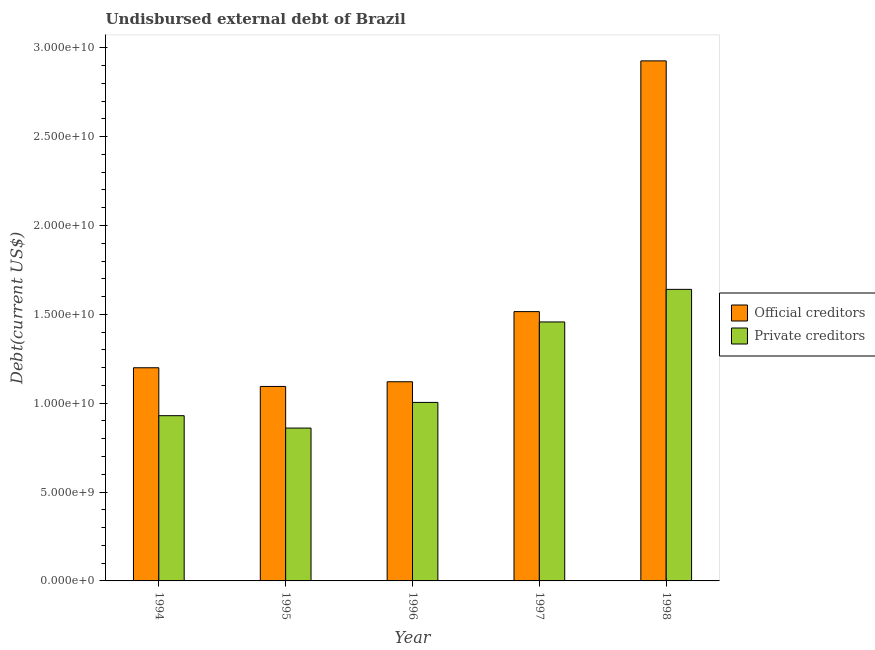Are the number of bars on each tick of the X-axis equal?
Keep it short and to the point. Yes. How many bars are there on the 1st tick from the right?
Provide a short and direct response. 2. What is the undisbursed external debt of private creditors in 1998?
Provide a succinct answer. 1.64e+1. Across all years, what is the maximum undisbursed external debt of private creditors?
Make the answer very short. 1.64e+1. Across all years, what is the minimum undisbursed external debt of private creditors?
Your response must be concise. 8.60e+09. What is the total undisbursed external debt of official creditors in the graph?
Provide a short and direct response. 7.86e+1. What is the difference between the undisbursed external debt of private creditors in 1994 and that in 1995?
Ensure brevity in your answer.  6.97e+08. What is the difference between the undisbursed external debt of private creditors in 1994 and the undisbursed external debt of official creditors in 1998?
Make the answer very short. -7.11e+09. What is the average undisbursed external debt of private creditors per year?
Ensure brevity in your answer.  1.18e+1. What is the ratio of the undisbursed external debt of private creditors in 1995 to that in 1997?
Give a very brief answer. 0.59. Is the undisbursed external debt of private creditors in 1995 less than that in 1998?
Provide a succinct answer. Yes. What is the difference between the highest and the second highest undisbursed external debt of private creditors?
Your answer should be very brief. 1.83e+09. What is the difference between the highest and the lowest undisbursed external debt of official creditors?
Offer a very short reply. 1.83e+1. In how many years, is the undisbursed external debt of official creditors greater than the average undisbursed external debt of official creditors taken over all years?
Make the answer very short. 1. What does the 1st bar from the left in 1995 represents?
Ensure brevity in your answer.  Official creditors. What does the 1st bar from the right in 1998 represents?
Offer a terse response. Private creditors. What is the difference between two consecutive major ticks on the Y-axis?
Make the answer very short. 5.00e+09. Does the graph contain grids?
Offer a terse response. No. How many legend labels are there?
Offer a terse response. 2. How are the legend labels stacked?
Your response must be concise. Vertical. What is the title of the graph?
Your answer should be compact. Undisbursed external debt of Brazil. Does "Resident workers" appear as one of the legend labels in the graph?
Keep it short and to the point. No. What is the label or title of the Y-axis?
Offer a very short reply. Debt(current US$). What is the Debt(current US$) in Official creditors in 1994?
Provide a succinct answer. 1.20e+1. What is the Debt(current US$) in Private creditors in 1994?
Keep it short and to the point. 9.30e+09. What is the Debt(current US$) of Official creditors in 1995?
Your answer should be very brief. 1.09e+1. What is the Debt(current US$) in Private creditors in 1995?
Your answer should be very brief. 8.60e+09. What is the Debt(current US$) of Official creditors in 1996?
Your answer should be compact. 1.12e+1. What is the Debt(current US$) in Private creditors in 1996?
Give a very brief answer. 1.00e+1. What is the Debt(current US$) of Official creditors in 1997?
Your answer should be compact. 1.52e+1. What is the Debt(current US$) in Private creditors in 1997?
Your answer should be compact. 1.46e+1. What is the Debt(current US$) in Official creditors in 1998?
Offer a very short reply. 2.93e+1. What is the Debt(current US$) in Private creditors in 1998?
Your answer should be very brief. 1.64e+1. Across all years, what is the maximum Debt(current US$) in Official creditors?
Offer a terse response. 2.93e+1. Across all years, what is the maximum Debt(current US$) of Private creditors?
Provide a succinct answer. 1.64e+1. Across all years, what is the minimum Debt(current US$) in Official creditors?
Offer a terse response. 1.09e+1. Across all years, what is the minimum Debt(current US$) of Private creditors?
Offer a terse response. 8.60e+09. What is the total Debt(current US$) of Official creditors in the graph?
Ensure brevity in your answer.  7.86e+1. What is the total Debt(current US$) in Private creditors in the graph?
Your response must be concise. 5.89e+1. What is the difference between the Debt(current US$) in Official creditors in 1994 and that in 1995?
Provide a succinct answer. 1.05e+09. What is the difference between the Debt(current US$) of Private creditors in 1994 and that in 1995?
Offer a very short reply. 6.97e+08. What is the difference between the Debt(current US$) in Official creditors in 1994 and that in 1996?
Make the answer very short. 7.88e+08. What is the difference between the Debt(current US$) in Private creditors in 1994 and that in 1996?
Give a very brief answer. -7.47e+08. What is the difference between the Debt(current US$) of Official creditors in 1994 and that in 1997?
Provide a short and direct response. -3.16e+09. What is the difference between the Debt(current US$) in Private creditors in 1994 and that in 1997?
Give a very brief answer. -5.27e+09. What is the difference between the Debt(current US$) in Official creditors in 1994 and that in 1998?
Make the answer very short. -1.73e+1. What is the difference between the Debt(current US$) of Private creditors in 1994 and that in 1998?
Provide a succinct answer. -7.11e+09. What is the difference between the Debt(current US$) of Official creditors in 1995 and that in 1996?
Provide a succinct answer. -2.64e+08. What is the difference between the Debt(current US$) of Private creditors in 1995 and that in 1996?
Ensure brevity in your answer.  -1.44e+09. What is the difference between the Debt(current US$) in Official creditors in 1995 and that in 1997?
Offer a very short reply. -4.21e+09. What is the difference between the Debt(current US$) in Private creditors in 1995 and that in 1997?
Give a very brief answer. -5.97e+09. What is the difference between the Debt(current US$) of Official creditors in 1995 and that in 1998?
Give a very brief answer. -1.83e+1. What is the difference between the Debt(current US$) in Private creditors in 1995 and that in 1998?
Give a very brief answer. -7.80e+09. What is the difference between the Debt(current US$) in Official creditors in 1996 and that in 1997?
Your answer should be compact. -3.95e+09. What is the difference between the Debt(current US$) of Private creditors in 1996 and that in 1997?
Your answer should be very brief. -4.53e+09. What is the difference between the Debt(current US$) in Official creditors in 1996 and that in 1998?
Your answer should be very brief. -1.81e+1. What is the difference between the Debt(current US$) of Private creditors in 1996 and that in 1998?
Give a very brief answer. -6.36e+09. What is the difference between the Debt(current US$) of Official creditors in 1997 and that in 1998?
Offer a very short reply. -1.41e+1. What is the difference between the Debt(current US$) of Private creditors in 1997 and that in 1998?
Keep it short and to the point. -1.83e+09. What is the difference between the Debt(current US$) in Official creditors in 1994 and the Debt(current US$) in Private creditors in 1995?
Your response must be concise. 3.39e+09. What is the difference between the Debt(current US$) of Official creditors in 1994 and the Debt(current US$) of Private creditors in 1996?
Make the answer very short. 1.95e+09. What is the difference between the Debt(current US$) in Official creditors in 1994 and the Debt(current US$) in Private creditors in 1997?
Your answer should be compact. -2.58e+09. What is the difference between the Debt(current US$) in Official creditors in 1994 and the Debt(current US$) in Private creditors in 1998?
Offer a terse response. -4.41e+09. What is the difference between the Debt(current US$) of Official creditors in 1995 and the Debt(current US$) of Private creditors in 1996?
Provide a succinct answer. 8.98e+08. What is the difference between the Debt(current US$) in Official creditors in 1995 and the Debt(current US$) in Private creditors in 1997?
Keep it short and to the point. -3.63e+09. What is the difference between the Debt(current US$) in Official creditors in 1995 and the Debt(current US$) in Private creditors in 1998?
Keep it short and to the point. -5.46e+09. What is the difference between the Debt(current US$) of Official creditors in 1996 and the Debt(current US$) of Private creditors in 1997?
Offer a terse response. -3.37e+09. What is the difference between the Debt(current US$) of Official creditors in 1996 and the Debt(current US$) of Private creditors in 1998?
Make the answer very short. -5.20e+09. What is the difference between the Debt(current US$) of Official creditors in 1997 and the Debt(current US$) of Private creditors in 1998?
Keep it short and to the point. -1.25e+09. What is the average Debt(current US$) in Official creditors per year?
Your answer should be compact. 1.57e+1. What is the average Debt(current US$) in Private creditors per year?
Offer a very short reply. 1.18e+1. In the year 1994, what is the difference between the Debt(current US$) in Official creditors and Debt(current US$) in Private creditors?
Provide a short and direct response. 2.70e+09. In the year 1995, what is the difference between the Debt(current US$) in Official creditors and Debt(current US$) in Private creditors?
Provide a succinct answer. 2.34e+09. In the year 1996, what is the difference between the Debt(current US$) in Official creditors and Debt(current US$) in Private creditors?
Your answer should be very brief. 1.16e+09. In the year 1997, what is the difference between the Debt(current US$) of Official creditors and Debt(current US$) of Private creditors?
Your answer should be compact. 5.82e+08. In the year 1998, what is the difference between the Debt(current US$) of Official creditors and Debt(current US$) of Private creditors?
Your answer should be very brief. 1.29e+1. What is the ratio of the Debt(current US$) in Official creditors in 1994 to that in 1995?
Your response must be concise. 1.1. What is the ratio of the Debt(current US$) in Private creditors in 1994 to that in 1995?
Your response must be concise. 1.08. What is the ratio of the Debt(current US$) of Official creditors in 1994 to that in 1996?
Provide a short and direct response. 1.07. What is the ratio of the Debt(current US$) in Private creditors in 1994 to that in 1996?
Your answer should be compact. 0.93. What is the ratio of the Debt(current US$) in Official creditors in 1994 to that in 1997?
Ensure brevity in your answer.  0.79. What is the ratio of the Debt(current US$) of Private creditors in 1994 to that in 1997?
Offer a very short reply. 0.64. What is the ratio of the Debt(current US$) of Official creditors in 1994 to that in 1998?
Make the answer very short. 0.41. What is the ratio of the Debt(current US$) of Private creditors in 1994 to that in 1998?
Your answer should be very brief. 0.57. What is the ratio of the Debt(current US$) of Official creditors in 1995 to that in 1996?
Keep it short and to the point. 0.98. What is the ratio of the Debt(current US$) of Private creditors in 1995 to that in 1996?
Your response must be concise. 0.86. What is the ratio of the Debt(current US$) of Official creditors in 1995 to that in 1997?
Give a very brief answer. 0.72. What is the ratio of the Debt(current US$) of Private creditors in 1995 to that in 1997?
Your answer should be compact. 0.59. What is the ratio of the Debt(current US$) in Official creditors in 1995 to that in 1998?
Your answer should be very brief. 0.37. What is the ratio of the Debt(current US$) in Private creditors in 1995 to that in 1998?
Provide a succinct answer. 0.52. What is the ratio of the Debt(current US$) in Official creditors in 1996 to that in 1997?
Provide a short and direct response. 0.74. What is the ratio of the Debt(current US$) of Private creditors in 1996 to that in 1997?
Keep it short and to the point. 0.69. What is the ratio of the Debt(current US$) of Official creditors in 1996 to that in 1998?
Provide a succinct answer. 0.38. What is the ratio of the Debt(current US$) in Private creditors in 1996 to that in 1998?
Offer a terse response. 0.61. What is the ratio of the Debt(current US$) of Official creditors in 1997 to that in 1998?
Your answer should be compact. 0.52. What is the ratio of the Debt(current US$) in Private creditors in 1997 to that in 1998?
Give a very brief answer. 0.89. What is the difference between the highest and the second highest Debt(current US$) of Official creditors?
Your answer should be compact. 1.41e+1. What is the difference between the highest and the second highest Debt(current US$) in Private creditors?
Your answer should be compact. 1.83e+09. What is the difference between the highest and the lowest Debt(current US$) in Official creditors?
Your answer should be compact. 1.83e+1. What is the difference between the highest and the lowest Debt(current US$) in Private creditors?
Provide a short and direct response. 7.80e+09. 